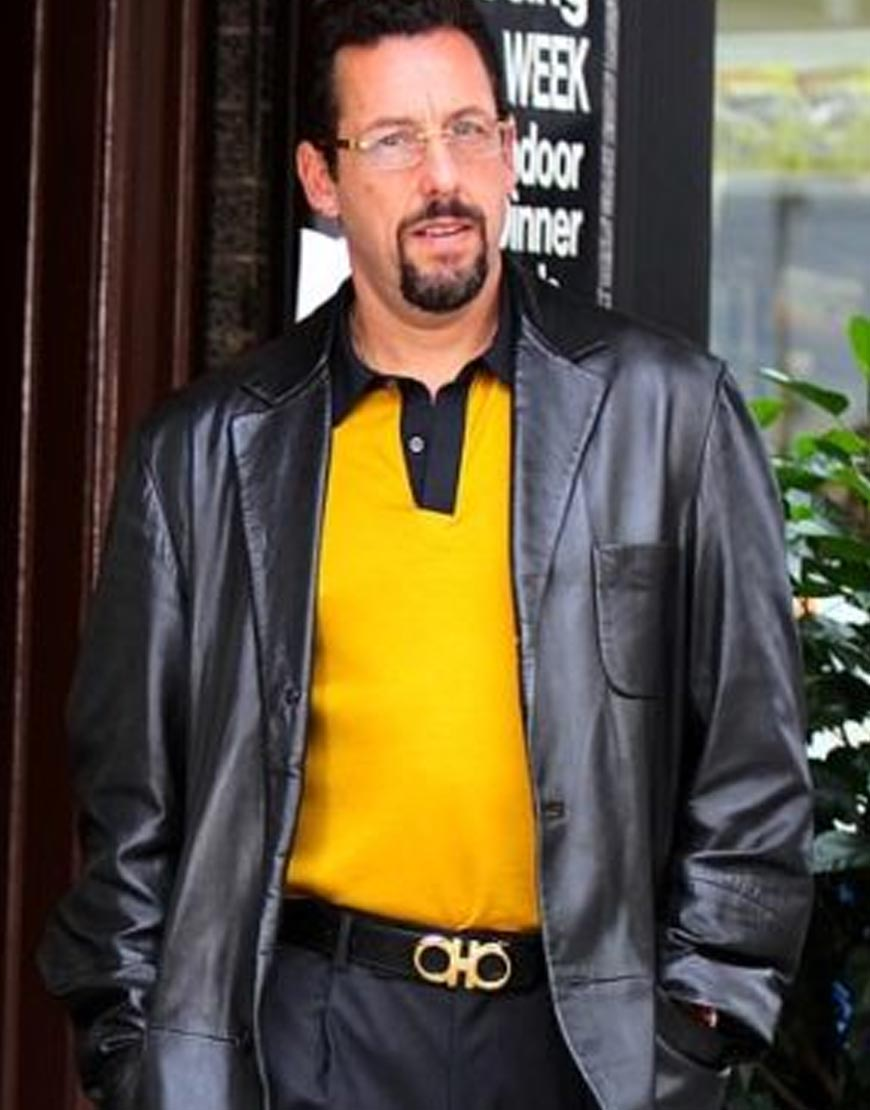What do his clothes say about his fashion sense or style? The man's choice of attire suggests a bold and confident fashion sense. He is wearing a combination of a bright yellow top paired with a black leather jacket and matching black pants, which creates a striking contrast. This indicates that he is not afraid to stand out and prefers to make a strong visual statement. The addition of a stylish belt with a distinctive buckle further enhances his look, suggesting a keen eye for fashion details. Overall, his outfit exudes a mix of casual elegance and edgy sophistication. 